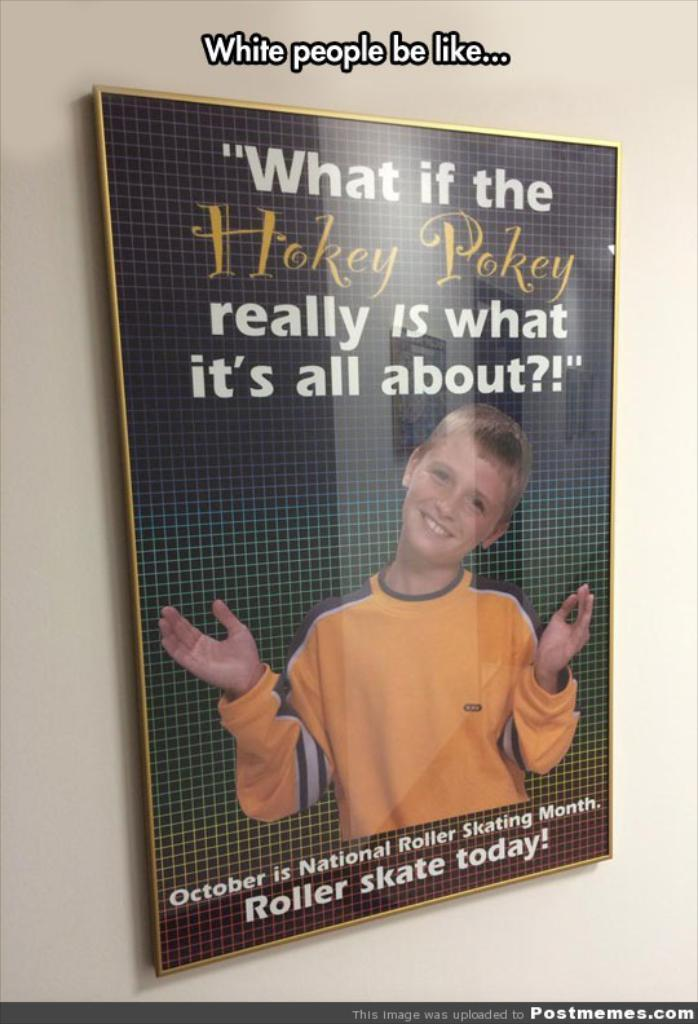<image>
Summarize the visual content of the image. An ad for roller skating says Roller skate today! 